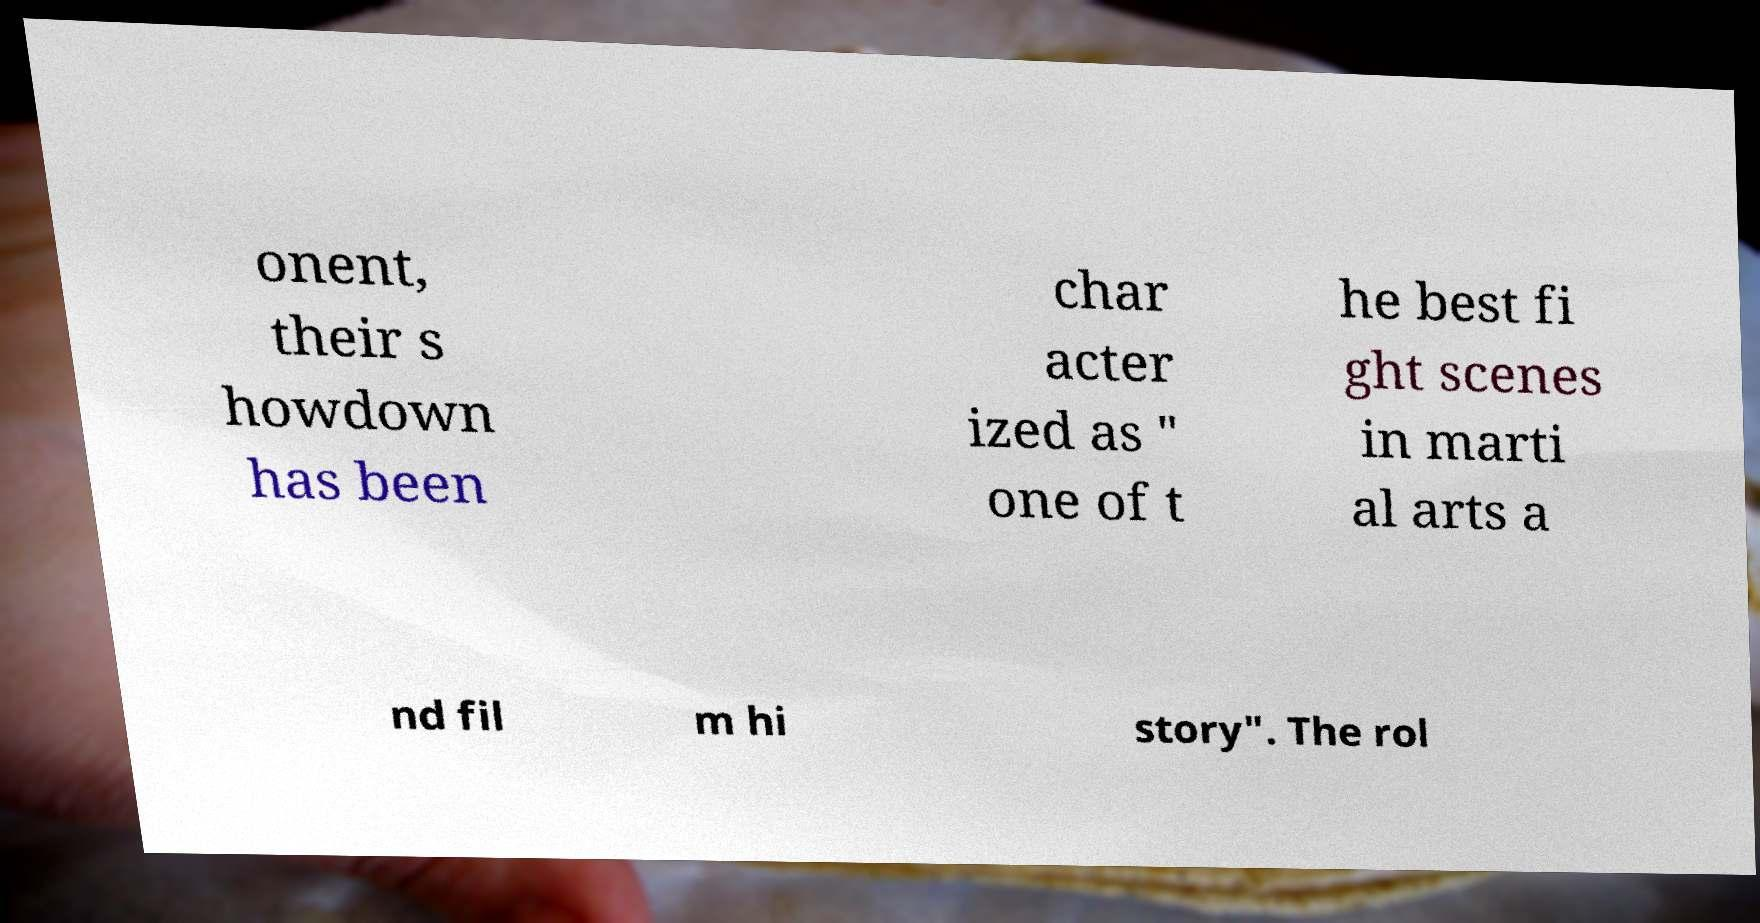There's text embedded in this image that I need extracted. Can you transcribe it verbatim? onent, their s howdown has been char acter ized as " one of t he best fi ght scenes in marti al arts a nd fil m hi story". The rol 